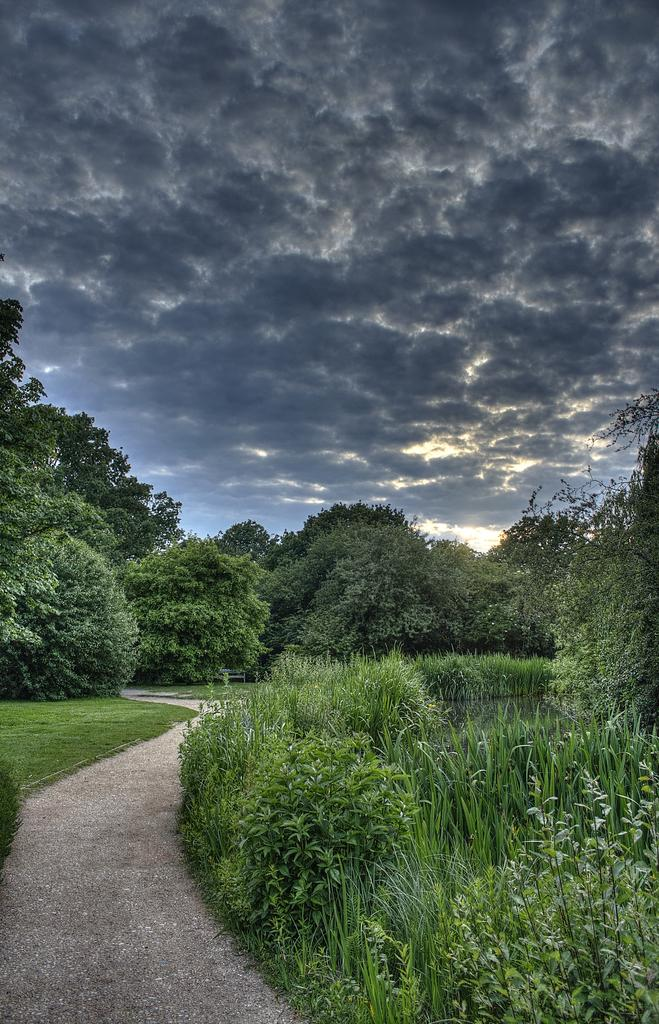What is the main feature of the image? There is a road in the image. What can be seen on both sides of the road? There is grass, plants, and trees on both sides of the road. What is present on the right side of the road? There is water on the right side of the road. What can be seen in the background of the image? There are clouds in the sky in the background of the image. Where is the meeting taking place in the image? There is no meeting taking place in the image; it features a road with surrounding vegetation and water. How many beds are visible in the image? There are no beds present in the image. 